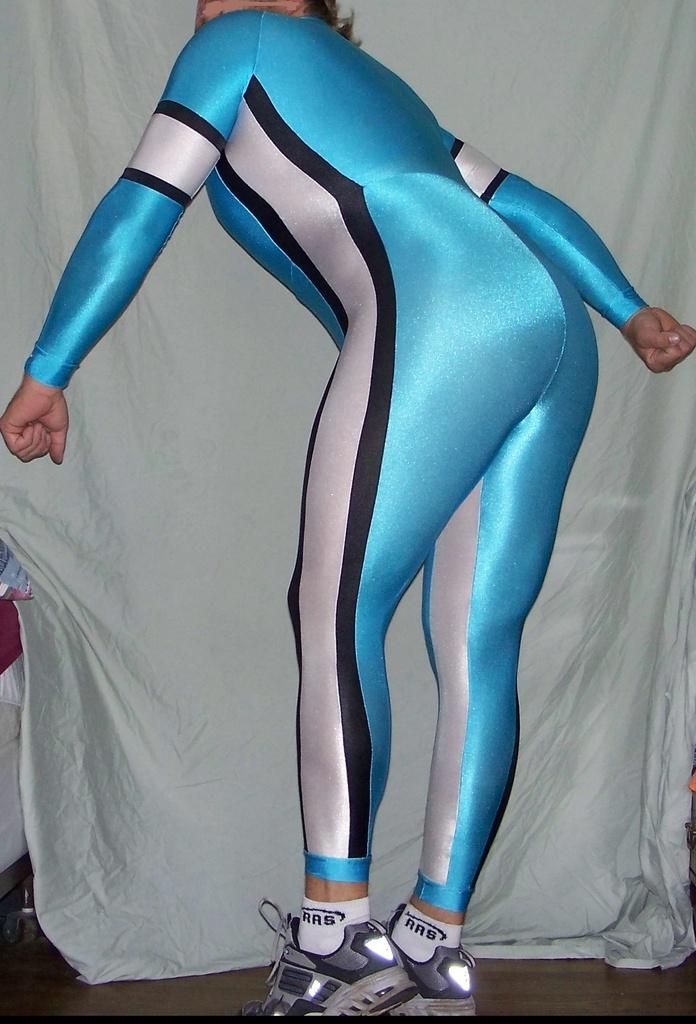What brand of socks?
Ensure brevity in your answer.  Ras. 